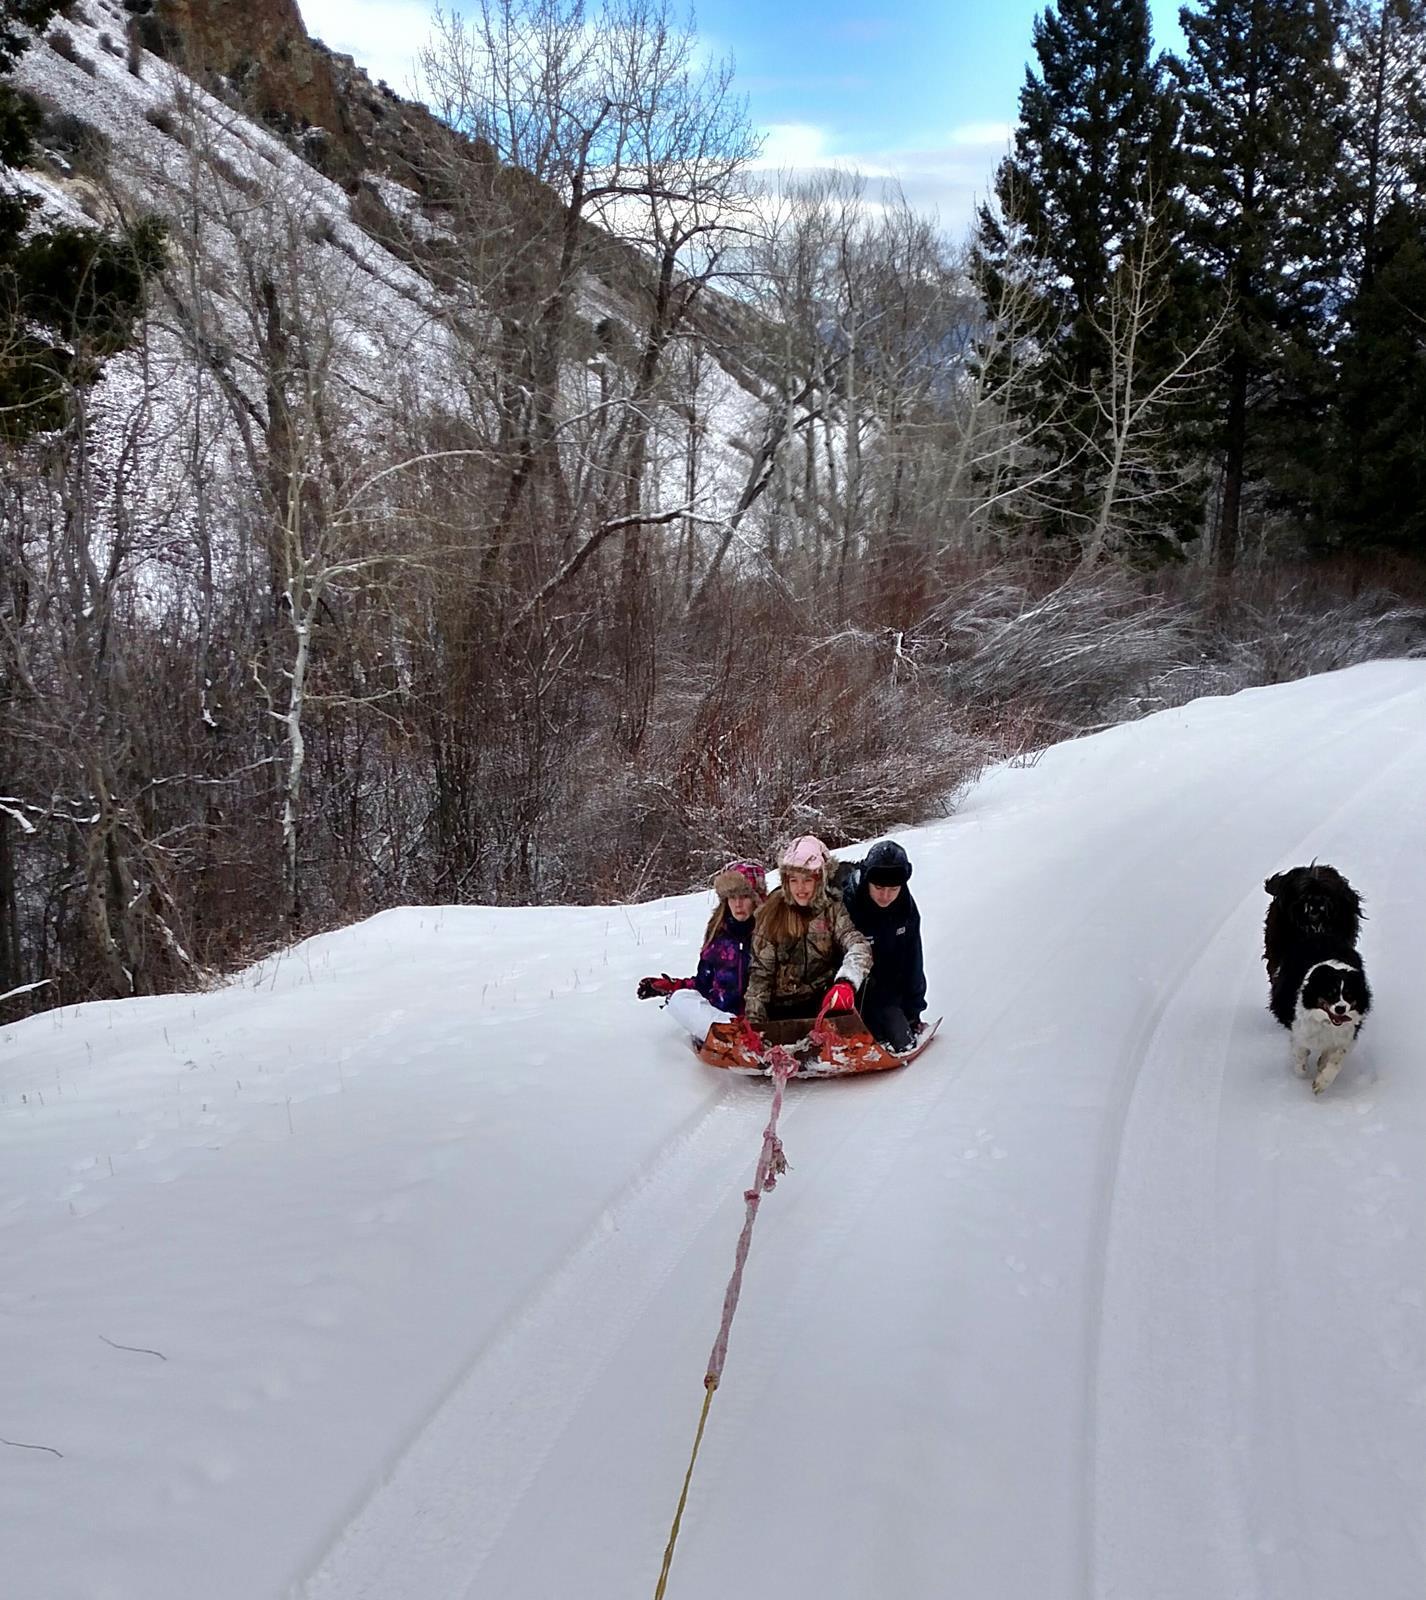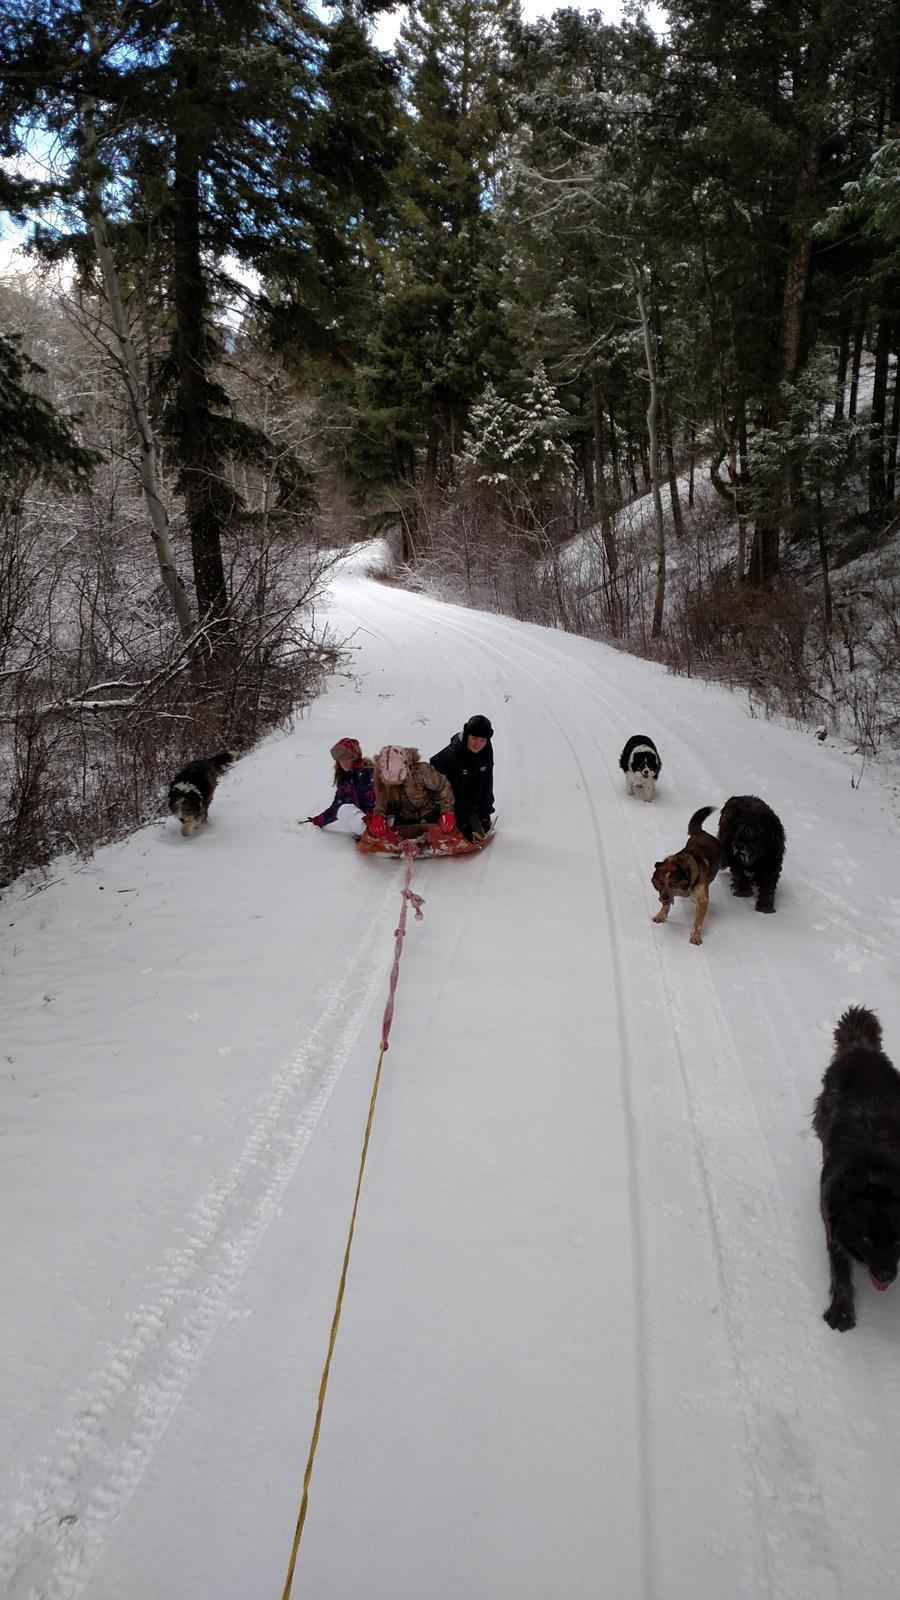The first image is the image on the left, the second image is the image on the right. Given the left and right images, does the statement "There are no more than 2 people present, dog sledding." hold true? Answer yes or no. No. 